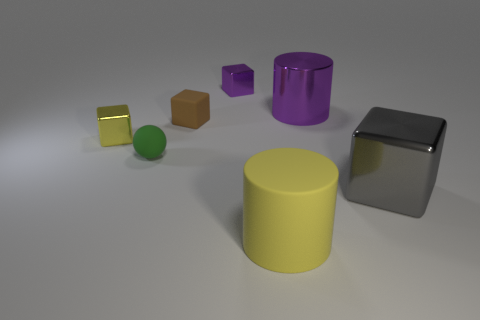The gray object that is the same shape as the brown rubber object is what size?
Provide a succinct answer. Large. Are there any other things that have the same shape as the small green object?
Give a very brief answer. No. What material is the yellow cube?
Your response must be concise. Metal. Are the block that is left of the tiny brown cube and the yellow cylinder made of the same material?
Your response must be concise. No. What is the shape of the tiny thing that is left of the tiny green rubber sphere?
Keep it short and to the point. Cube. There is a yellow cube that is the same size as the green sphere; what is it made of?
Provide a short and direct response. Metal. How many objects are shiny objects that are to the left of the large gray metallic block or metallic blocks in front of the sphere?
Offer a very short reply. 4. There is a yellow block that is made of the same material as the large gray object; what is its size?
Keep it short and to the point. Small. What number of shiny objects are either large cylinders or gray things?
Give a very brief answer. 2. What size is the yellow cylinder?
Ensure brevity in your answer.  Large. 